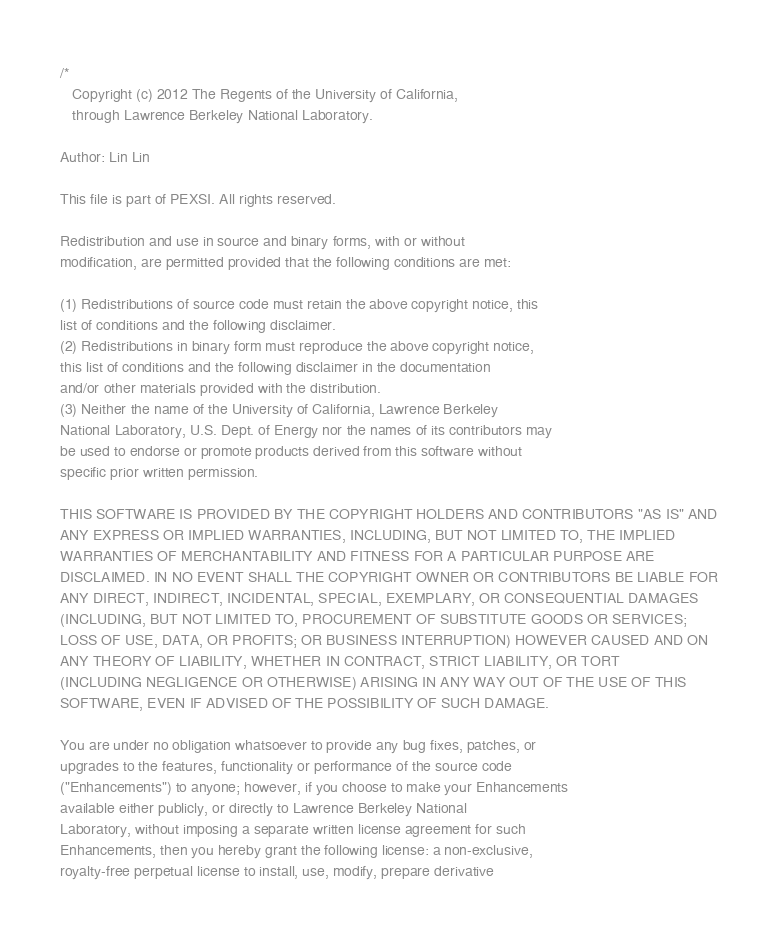Convert code to text. <code><loc_0><loc_0><loc_500><loc_500><_C++_>/*
   Copyright (c) 2012 The Regents of the University of California,
   through Lawrence Berkeley National Laboratory.

Author: Lin Lin

This file is part of PEXSI. All rights reserved.

Redistribution and use in source and binary forms, with or without
modification, are permitted provided that the following conditions are met:

(1) Redistributions of source code must retain the above copyright notice, this
list of conditions and the following disclaimer.
(2) Redistributions in binary form must reproduce the above copyright notice,
this list of conditions and the following disclaimer in the documentation
and/or other materials provided with the distribution.
(3) Neither the name of the University of California, Lawrence Berkeley
National Laboratory, U.S. Dept. of Energy nor the names of its contributors may
be used to endorse or promote products derived from this software without
specific prior written permission.

THIS SOFTWARE IS PROVIDED BY THE COPYRIGHT HOLDERS AND CONTRIBUTORS "AS IS" AND
ANY EXPRESS OR IMPLIED WARRANTIES, INCLUDING, BUT NOT LIMITED TO, THE IMPLIED
WARRANTIES OF MERCHANTABILITY AND FITNESS FOR A PARTICULAR PURPOSE ARE
DISCLAIMED. IN NO EVENT SHALL THE COPYRIGHT OWNER OR CONTRIBUTORS BE LIABLE FOR
ANY DIRECT, INDIRECT, INCIDENTAL, SPECIAL, EXEMPLARY, OR CONSEQUENTIAL DAMAGES
(INCLUDING, BUT NOT LIMITED TO, PROCUREMENT OF SUBSTITUTE GOODS OR SERVICES;
LOSS OF USE, DATA, OR PROFITS; OR BUSINESS INTERRUPTION) HOWEVER CAUSED AND ON
ANY THEORY OF LIABILITY, WHETHER IN CONTRACT, STRICT LIABILITY, OR TORT
(INCLUDING NEGLIGENCE OR OTHERWISE) ARISING IN ANY WAY OUT OF THE USE OF THIS
SOFTWARE, EVEN IF ADVISED OF THE POSSIBILITY OF SUCH DAMAGE.

You are under no obligation whatsoever to provide any bug fixes, patches, or
upgrades to the features, functionality or performance of the source code
("Enhancements") to anyone; however, if you choose to make your Enhancements
available either publicly, or directly to Lawrence Berkeley National
Laboratory, without imposing a separate written license agreement for such
Enhancements, then you hereby grant the following license: a non-exclusive,
royalty-free perpetual license to install, use, modify, prepare derivative</code> 